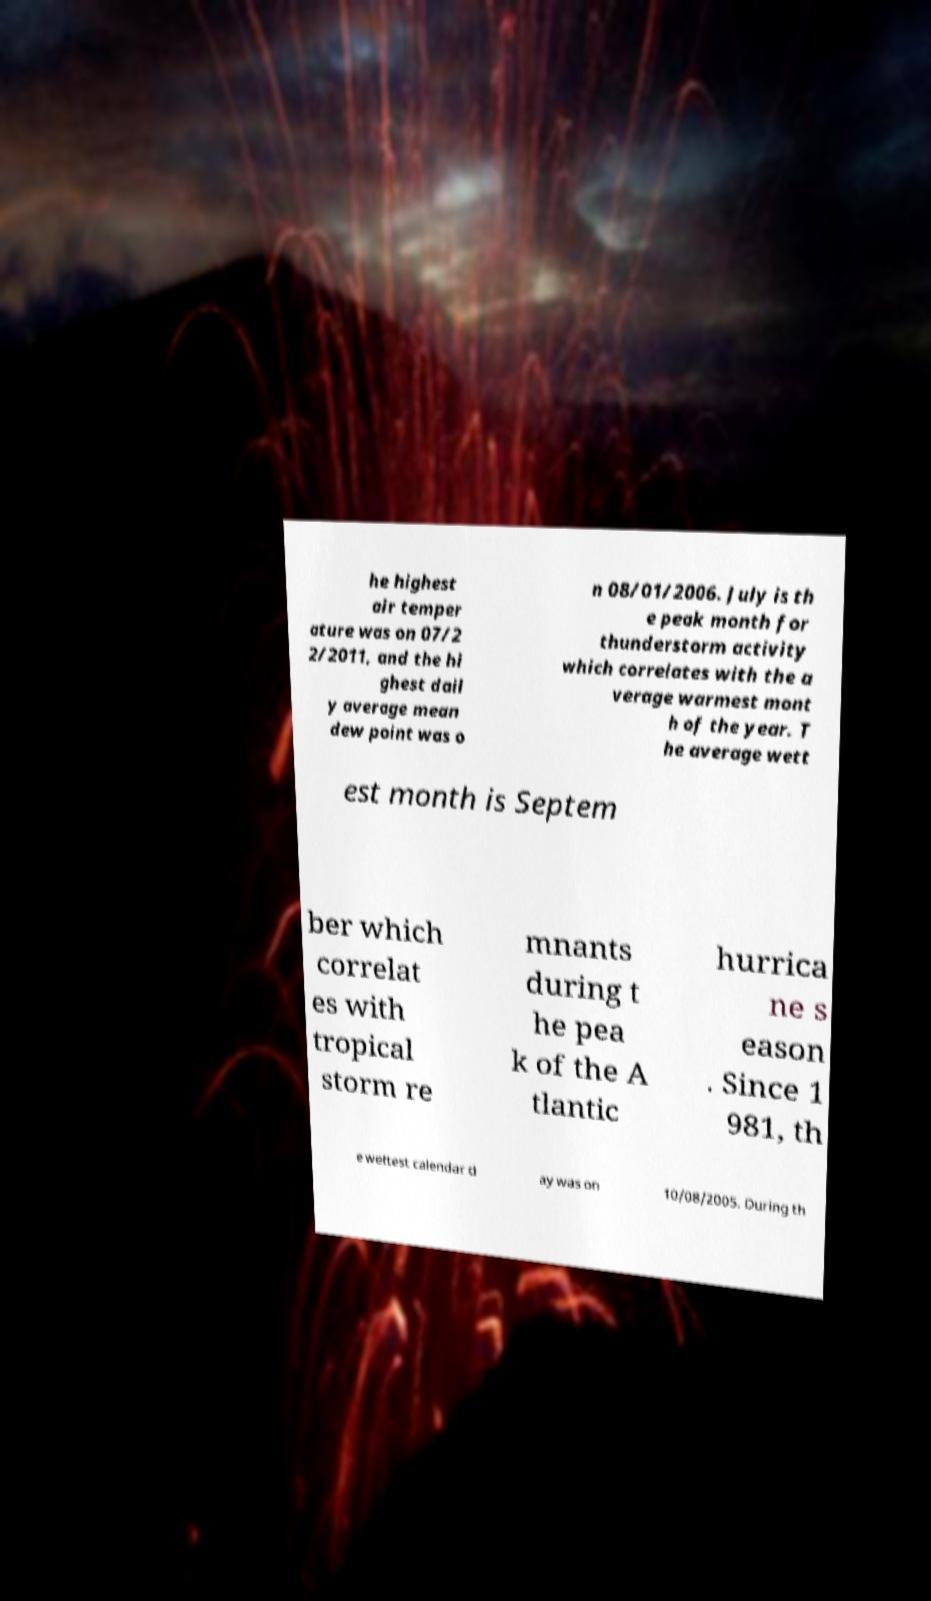Can you accurately transcribe the text from the provided image for me? he highest air temper ature was on 07/2 2/2011, and the hi ghest dail y average mean dew point was o n 08/01/2006. July is th e peak month for thunderstorm activity which correlates with the a verage warmest mont h of the year. T he average wett est month is Septem ber which correlat es with tropical storm re mnants during t he pea k of the A tlantic hurrica ne s eason . Since 1 981, th e wettest calendar d ay was on 10/08/2005. During th 